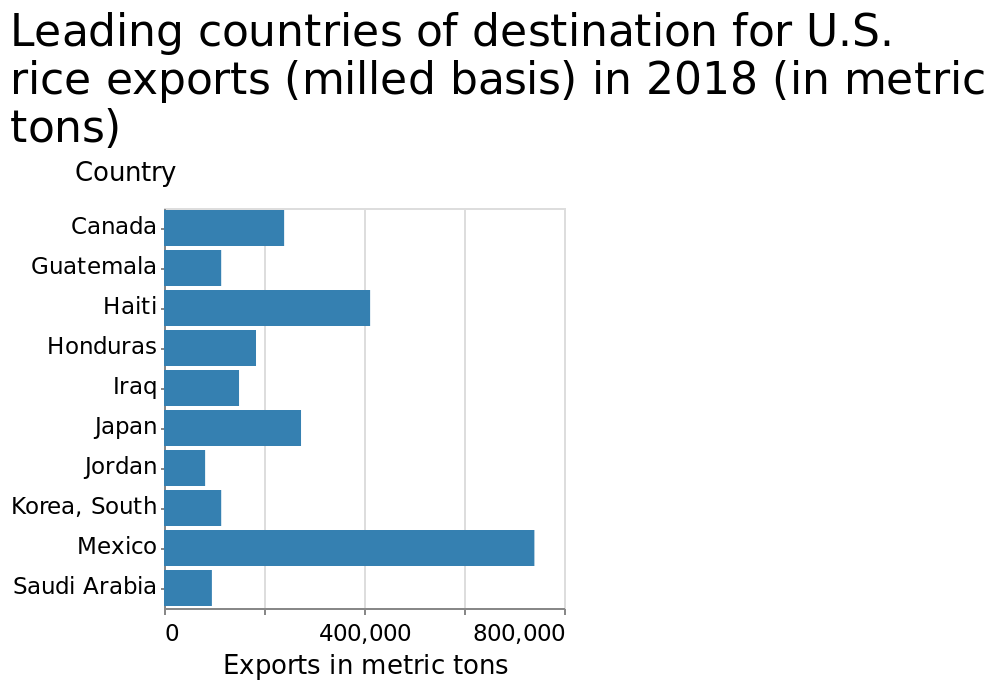<image>
How is the y-axis measured in the bar chart? The y-axis measures countries as a categorical scale, starting with Canada and ending with Saudi Arabia. What is the ranking of Mexico in terms of rice exports?  Mexico seems to be high in the rankings in terms of rice exports. please describe the details of the chart This bar chart is titled Leading countries of destination for U.S. rice exports (milled basis) in 2018 (in metric tons). The x-axis shows Exports in metric tons as linear scale with a minimum of 0 and a maximum of 800,000 while the y-axis measures Country as categorical scale starting at Canada and ending at Saudi Arabia. 